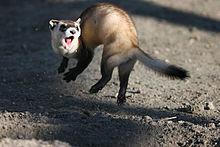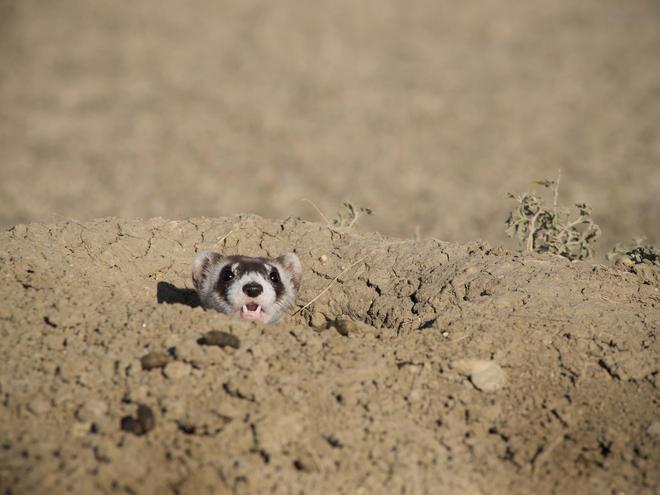The first image is the image on the left, the second image is the image on the right. Analyze the images presented: Is the assertion "An animal in one image is caught leaping in mid-air." valid? Answer yes or no. Yes. The first image is the image on the left, the second image is the image on the right. For the images shown, is this caption "There are 3 total ferrets." true? Answer yes or no. No. The first image is the image on the left, the second image is the image on the right. Analyze the images presented: Is the assertion "In both images, the ferret's head is stretched up to gaze about." valid? Answer yes or no. No. The first image is the image on the left, the second image is the image on the right. Evaluate the accuracy of this statement regarding the images: "There are two ferrets total.". Is it true? Answer yes or no. Yes. 